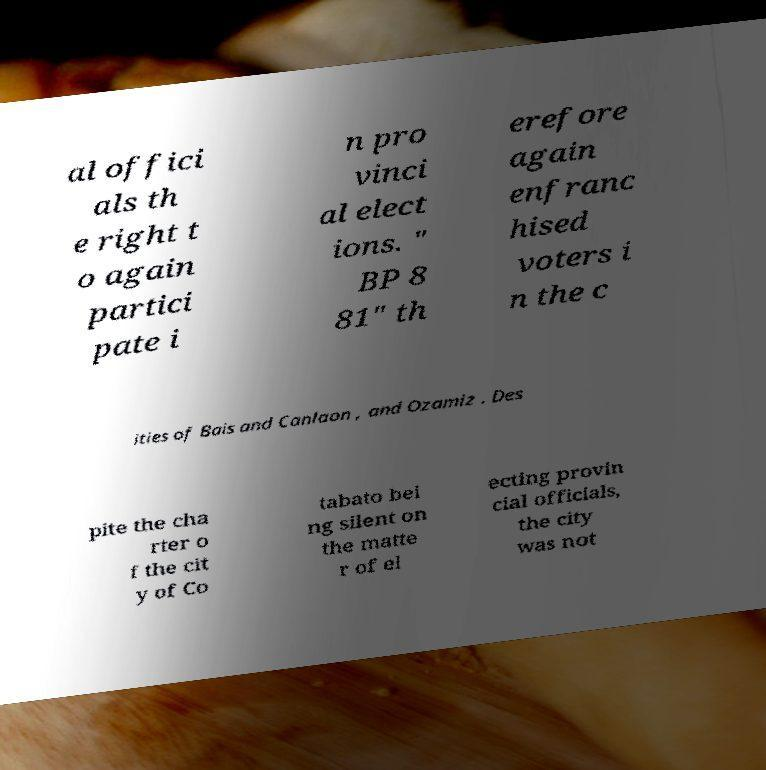Can you accurately transcribe the text from the provided image for me? al offici als th e right t o again partici pate i n pro vinci al elect ions. " BP 8 81" th erefore again enfranc hised voters i n the c ities of Bais and Canlaon , and Ozamiz . Des pite the cha rter o f the cit y of Co tabato bei ng silent on the matte r of el ecting provin cial officials, the city was not 